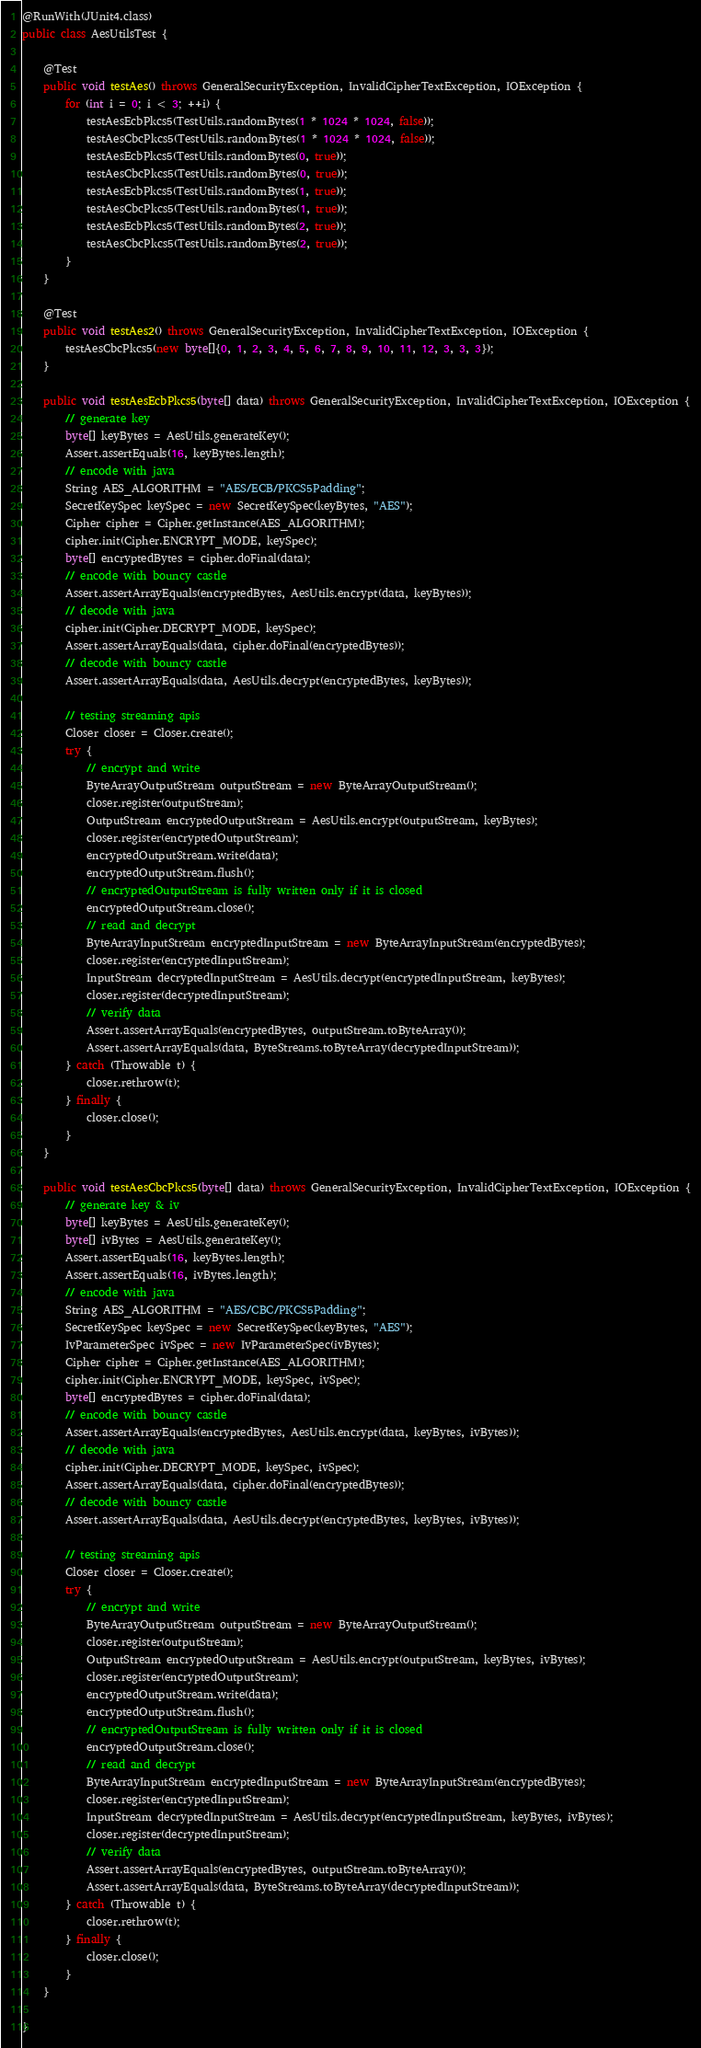<code> <loc_0><loc_0><loc_500><loc_500><_Java_>@RunWith(JUnit4.class)
public class AesUtilsTest {

    @Test
    public void testAes() throws GeneralSecurityException, InvalidCipherTextException, IOException {
        for (int i = 0; i < 3; ++i) {
            testAesEcbPkcs5(TestUtils.randomBytes(1 * 1024 * 1024, false));
            testAesCbcPkcs5(TestUtils.randomBytes(1 * 1024 * 1024, false));
            testAesEcbPkcs5(TestUtils.randomBytes(0, true));
            testAesCbcPkcs5(TestUtils.randomBytes(0, true));
            testAesEcbPkcs5(TestUtils.randomBytes(1, true));
            testAesCbcPkcs5(TestUtils.randomBytes(1, true));
            testAesEcbPkcs5(TestUtils.randomBytes(2, true));
            testAesCbcPkcs5(TestUtils.randomBytes(2, true));
        }
    }

    @Test
    public void testAes2() throws GeneralSecurityException, InvalidCipherTextException, IOException {
        testAesCbcPkcs5(new byte[]{0, 1, 2, 3, 4, 5, 6, 7, 8, 9, 10, 11, 12, 3, 3, 3});
    }

    public void testAesEcbPkcs5(byte[] data) throws GeneralSecurityException, InvalidCipherTextException, IOException {
        // generate key
        byte[] keyBytes = AesUtils.generateKey();
        Assert.assertEquals(16, keyBytes.length);
        // encode with java
        String AES_ALGORITHM = "AES/ECB/PKCS5Padding";
        SecretKeySpec keySpec = new SecretKeySpec(keyBytes, "AES");
        Cipher cipher = Cipher.getInstance(AES_ALGORITHM);
        cipher.init(Cipher.ENCRYPT_MODE, keySpec);
        byte[] encryptedBytes = cipher.doFinal(data);
        // encode with bouncy castle
        Assert.assertArrayEquals(encryptedBytes, AesUtils.encrypt(data, keyBytes));
        // decode with java
        cipher.init(Cipher.DECRYPT_MODE, keySpec);
        Assert.assertArrayEquals(data, cipher.doFinal(encryptedBytes));
        // decode with bouncy castle
        Assert.assertArrayEquals(data, AesUtils.decrypt(encryptedBytes, keyBytes));

        // testing streaming apis
        Closer closer = Closer.create();
        try {
            // encrypt and write
            ByteArrayOutputStream outputStream = new ByteArrayOutputStream();
            closer.register(outputStream);
            OutputStream encryptedOutputStream = AesUtils.encrypt(outputStream, keyBytes);
            closer.register(encryptedOutputStream);
            encryptedOutputStream.write(data);
            encryptedOutputStream.flush();
            // encryptedOutputStream is fully written only if it is closed
            encryptedOutputStream.close();
            // read and decrypt
            ByteArrayInputStream encryptedInputStream = new ByteArrayInputStream(encryptedBytes);
            closer.register(encryptedInputStream);
            InputStream decryptedInputStream = AesUtils.decrypt(encryptedInputStream, keyBytes);
            closer.register(decryptedInputStream);
            // verify data
            Assert.assertArrayEquals(encryptedBytes, outputStream.toByteArray());
            Assert.assertArrayEquals(data, ByteStreams.toByteArray(decryptedInputStream));
        } catch (Throwable t) {
            closer.rethrow(t);
        } finally {
            closer.close();
        }
    }

    public void testAesCbcPkcs5(byte[] data) throws GeneralSecurityException, InvalidCipherTextException, IOException {
        // generate key & iv
        byte[] keyBytes = AesUtils.generateKey();
        byte[] ivBytes = AesUtils.generateKey();
        Assert.assertEquals(16, keyBytes.length);
        Assert.assertEquals(16, ivBytes.length);
        // encode with java
        String AES_ALGORITHM = "AES/CBC/PKCS5Padding";
        SecretKeySpec keySpec = new SecretKeySpec(keyBytes, "AES");
        IvParameterSpec ivSpec = new IvParameterSpec(ivBytes);
        Cipher cipher = Cipher.getInstance(AES_ALGORITHM);
        cipher.init(Cipher.ENCRYPT_MODE, keySpec, ivSpec);
        byte[] encryptedBytes = cipher.doFinal(data);
        // encode with bouncy castle
        Assert.assertArrayEquals(encryptedBytes, AesUtils.encrypt(data, keyBytes, ivBytes));
        // decode with java
        cipher.init(Cipher.DECRYPT_MODE, keySpec, ivSpec);
        Assert.assertArrayEquals(data, cipher.doFinal(encryptedBytes));
        // decode with bouncy castle
        Assert.assertArrayEquals(data, AesUtils.decrypt(encryptedBytes, keyBytes, ivBytes));

        // testing streaming apis
        Closer closer = Closer.create();
        try {
            // encrypt and write
            ByteArrayOutputStream outputStream = new ByteArrayOutputStream();
            closer.register(outputStream);
            OutputStream encryptedOutputStream = AesUtils.encrypt(outputStream, keyBytes, ivBytes);
            closer.register(encryptedOutputStream);
            encryptedOutputStream.write(data);
            encryptedOutputStream.flush();
            // encryptedOutputStream is fully written only if it is closed
            encryptedOutputStream.close();
            // read and decrypt
            ByteArrayInputStream encryptedInputStream = new ByteArrayInputStream(encryptedBytes);
            closer.register(encryptedInputStream);
            InputStream decryptedInputStream = AesUtils.decrypt(encryptedInputStream, keyBytes, ivBytes);
            closer.register(decryptedInputStream);
            // verify data
            Assert.assertArrayEquals(encryptedBytes, outputStream.toByteArray());
            Assert.assertArrayEquals(data, ByteStreams.toByteArray(decryptedInputStream));
        } catch (Throwable t) {
            closer.rethrow(t);
        } finally {
            closer.close();
        }
    }

}
</code> 